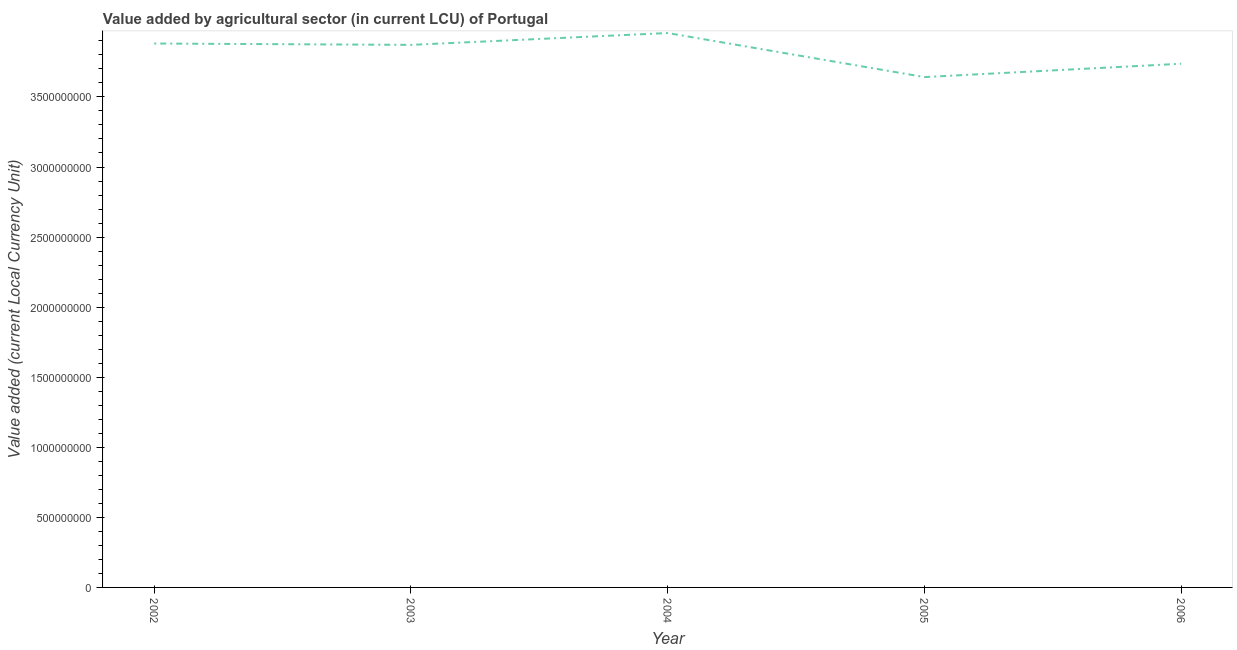What is the value added by agriculture sector in 2005?
Ensure brevity in your answer.  3.64e+09. Across all years, what is the maximum value added by agriculture sector?
Offer a very short reply. 3.96e+09. Across all years, what is the minimum value added by agriculture sector?
Offer a very short reply. 3.64e+09. In which year was the value added by agriculture sector minimum?
Provide a succinct answer. 2005. What is the sum of the value added by agriculture sector?
Keep it short and to the point. 1.91e+1. What is the difference between the value added by agriculture sector in 2002 and 2003?
Provide a succinct answer. 9.65e+06. What is the average value added by agriculture sector per year?
Your answer should be compact. 3.82e+09. What is the median value added by agriculture sector?
Ensure brevity in your answer.  3.87e+09. In how many years, is the value added by agriculture sector greater than 1900000000 LCU?
Your response must be concise. 5. What is the ratio of the value added by agriculture sector in 2002 to that in 2004?
Your answer should be very brief. 0.98. What is the difference between the highest and the second highest value added by agriculture sector?
Keep it short and to the point. 7.49e+07. What is the difference between the highest and the lowest value added by agriculture sector?
Ensure brevity in your answer.  3.14e+08. In how many years, is the value added by agriculture sector greater than the average value added by agriculture sector taken over all years?
Your answer should be compact. 3. How many years are there in the graph?
Your answer should be compact. 5. Are the values on the major ticks of Y-axis written in scientific E-notation?
Your answer should be compact. No. Does the graph contain any zero values?
Keep it short and to the point. No. Does the graph contain grids?
Your answer should be compact. No. What is the title of the graph?
Ensure brevity in your answer.  Value added by agricultural sector (in current LCU) of Portugal. What is the label or title of the X-axis?
Your answer should be very brief. Year. What is the label or title of the Y-axis?
Your answer should be very brief. Value added (current Local Currency Unit). What is the Value added (current Local Currency Unit) in 2002?
Your response must be concise. 3.88e+09. What is the Value added (current Local Currency Unit) in 2003?
Keep it short and to the point. 3.87e+09. What is the Value added (current Local Currency Unit) in 2004?
Offer a terse response. 3.96e+09. What is the Value added (current Local Currency Unit) in 2005?
Provide a short and direct response. 3.64e+09. What is the Value added (current Local Currency Unit) in 2006?
Provide a short and direct response. 3.74e+09. What is the difference between the Value added (current Local Currency Unit) in 2002 and 2003?
Offer a very short reply. 9.65e+06. What is the difference between the Value added (current Local Currency Unit) in 2002 and 2004?
Provide a short and direct response. -7.49e+07. What is the difference between the Value added (current Local Currency Unit) in 2002 and 2005?
Make the answer very short. 2.39e+08. What is the difference between the Value added (current Local Currency Unit) in 2002 and 2006?
Offer a terse response. 1.44e+08. What is the difference between the Value added (current Local Currency Unit) in 2003 and 2004?
Give a very brief answer. -8.45e+07. What is the difference between the Value added (current Local Currency Unit) in 2003 and 2005?
Your answer should be very brief. 2.30e+08. What is the difference between the Value added (current Local Currency Unit) in 2003 and 2006?
Your response must be concise. 1.35e+08. What is the difference between the Value added (current Local Currency Unit) in 2004 and 2005?
Your response must be concise. 3.14e+08. What is the difference between the Value added (current Local Currency Unit) in 2004 and 2006?
Keep it short and to the point. 2.19e+08. What is the difference between the Value added (current Local Currency Unit) in 2005 and 2006?
Make the answer very short. -9.51e+07. What is the ratio of the Value added (current Local Currency Unit) in 2002 to that in 2004?
Ensure brevity in your answer.  0.98. What is the ratio of the Value added (current Local Currency Unit) in 2002 to that in 2005?
Offer a terse response. 1.07. What is the ratio of the Value added (current Local Currency Unit) in 2002 to that in 2006?
Provide a short and direct response. 1.04. What is the ratio of the Value added (current Local Currency Unit) in 2003 to that in 2005?
Ensure brevity in your answer.  1.06. What is the ratio of the Value added (current Local Currency Unit) in 2003 to that in 2006?
Your answer should be very brief. 1.04. What is the ratio of the Value added (current Local Currency Unit) in 2004 to that in 2005?
Your response must be concise. 1.09. What is the ratio of the Value added (current Local Currency Unit) in 2004 to that in 2006?
Offer a very short reply. 1.06. What is the ratio of the Value added (current Local Currency Unit) in 2005 to that in 2006?
Your answer should be very brief. 0.97. 